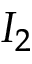Convert formula to latex. <formula><loc_0><loc_0><loc_500><loc_500>I _ { 2 }</formula> 